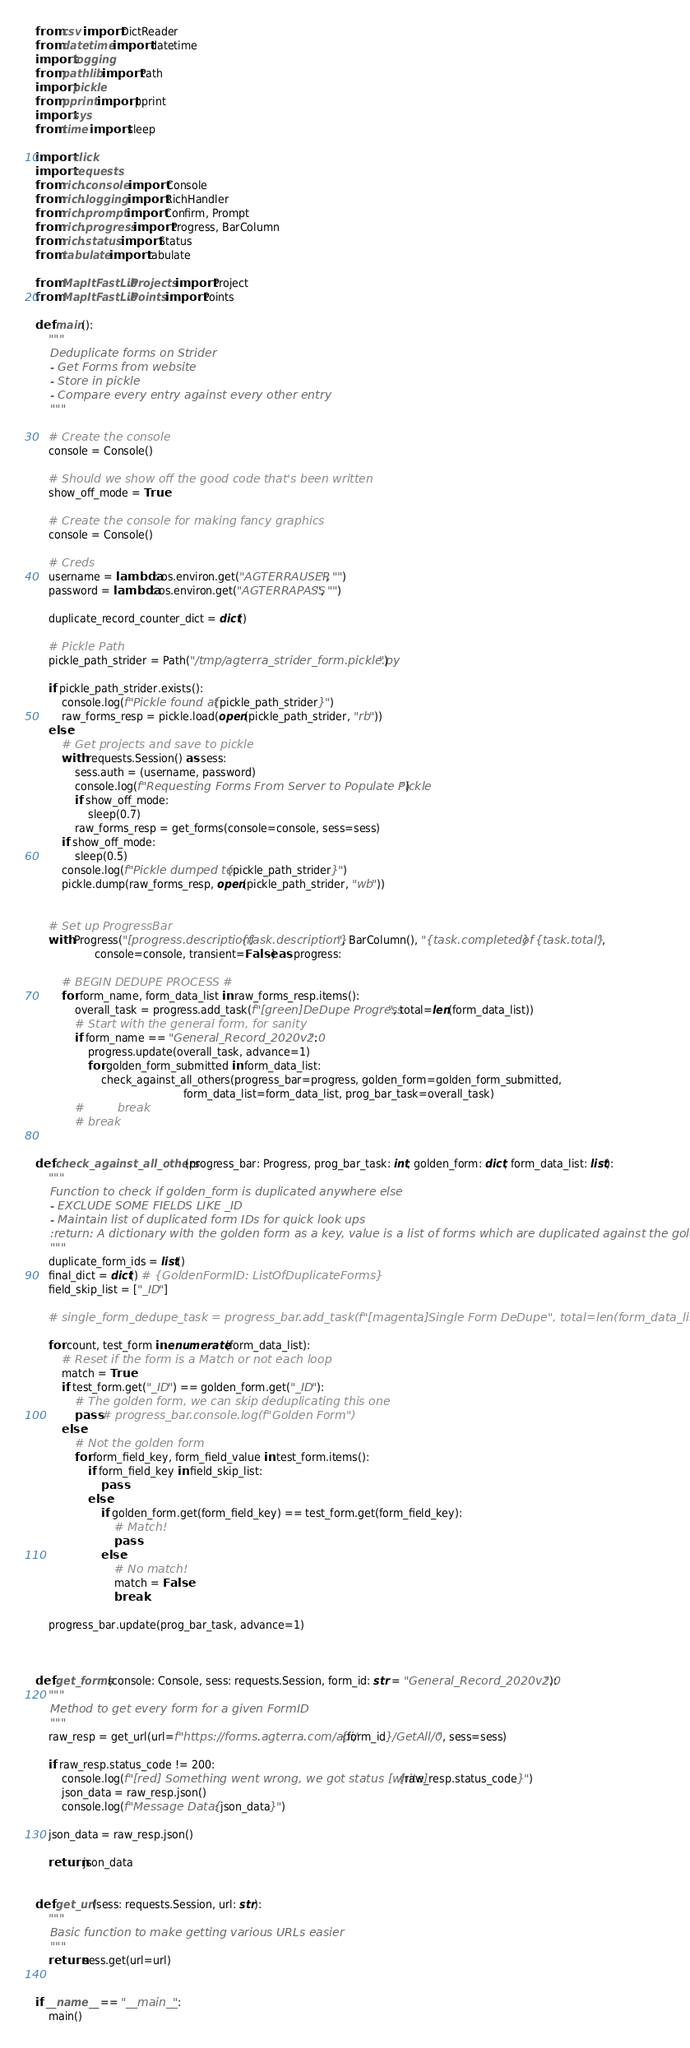Convert code to text. <code><loc_0><loc_0><loc_500><loc_500><_Python_>from csv import DictReader
from datetime import datetime
import logging
from pathlib import Path
import pickle
from pprint import pprint
import sys
from time import sleep

import click
import requests
from rich.console import Console
from rich.logging import RichHandler
from rich.prompt import Confirm, Prompt
from rich.progress import Progress, BarColumn
from rich.status import Status
from tabulate import tabulate

from MapItFastLib.Projects import Project
from MapItFastLib.Points import Points

def main():
    """
    Deduplicate forms on Strider
    - Get Forms from website
    - Store in pickle
    - Compare every entry against every other entry
    """

    # Create the console
    console = Console()

    # Should we show off the good code that's been written
    show_off_mode = True

    # Create the console for making fancy graphics
    console = Console()

    # Creds
    username = lambda: os.environ.get("AGTERRAUSER", "")
    password = lambda: os.environ.get("AGTERRAPASS", "")

    duplicate_record_counter_dict = dict()

    # Pickle Path
    pickle_path_strider = Path("/tmp/agterra_strider_form.pickle.py")

    if pickle_path_strider.exists():
        console.log(f"Pickle found at {pickle_path_strider}")
        raw_forms_resp = pickle.load(open(pickle_path_strider, "rb"))
    else:
        # Get projects and save to pickle
        with requests.Session() as sess:
            sess.auth = (username, password)
            console.log(f"Requesting Forms From Server to Populate Pickle")
            if show_off_mode:
                sleep(0.7)
            raw_forms_resp = get_forms(console=console, sess=sess)
        if show_off_mode:
            sleep(0.5)
        console.log(f"Pickle dumped to {pickle_path_strider}")
        pickle.dump(raw_forms_resp, open(pickle_path_strider, "wb"))


    # Set up ProgressBar
    with Progress("[progress.description]{task.description}", BarColumn(), "{task.completed} of {task.total}",
                  console=console, transient=False) as progress:

        # BEGIN DEDUPE PROCESS #
        for form_name, form_data_list in raw_forms_resp.items():
            overall_task = progress.add_task(f"[green]DeDupe Progress", total=len(form_data_list))
            # Start with the general form, for sanity
            if form_name == "General_Record_2020v2.0":
                progress.update(overall_task, advance=1)
                for golden_form_submitted in form_data_list:
                    check_against_all_others(progress_bar=progress, golden_form=golden_form_submitted,
                                             form_data_list=form_data_list, prog_bar_task=overall_task)
            #         break
            # break


def check_against_all_others(progress_bar: Progress, prog_bar_task: int, golden_form: dict, form_data_list: list):
    """
    Function to check if golden_form is duplicated anywhere else
    - EXCLUDE SOME FIELDS LIKE _ID
    - Maintain list of duplicated form IDs for quick look ups
    :return: A dictionary with the golden form as a key, value is a list of forms which are duplicated against the golden one
    """
    duplicate_form_ids = list()
    final_dict = dict() # {GoldenFormID: ListOfDuplicateForms}
    field_skip_list = ["_ID"]

    # single_form_dedupe_task = progress_bar.add_task(f"[magenta]Single Form DeDupe", total=len(form_data_list))

    for count, test_form in enumerate(form_data_list):
        # Reset if the form is a Match or not each loop
        match = True
        if test_form.get("_ID") == golden_form.get("_ID"):
            # The golden form, we can skip deduplicating this one
            pass # progress_bar.console.log(f"Golden Form")
        else:
            # Not the golden form
            for form_field_key, form_field_value in test_form.items():
                if form_field_key in field_skip_list:
                    pass
                else:
                    if golden_form.get(form_field_key) == test_form.get(form_field_key):
                        # Match!
                        pass
                    else:
                        # No match!
                        match = False
                        break

    progress_bar.update(prog_bar_task, advance=1)



def get_forms(console: Console, sess: requests.Session, form_id: str = "General_Record_2020v2.0"):
    """
    Method to get every form for a given FormID
    """
    raw_resp = get_url(url=f"https://forms.agterra.com/api/{form_id}/GetAll/0", sess=sess)

    if raw_resp.status_code != 200:
        console.log(f"[red] Something went wrong, we got status [white]{raw_resp.status_code}")
        json_data = raw_resp.json()
        console.log(f"Message Data: {json_data}")

    json_data = raw_resp.json()

    return json_data


def get_url(sess: requests.Session, url: str):
    """
    Basic function to make getting various URLs easier
    """
    return sess.get(url=url)


if __name__ == "__main__":
    main()</code> 